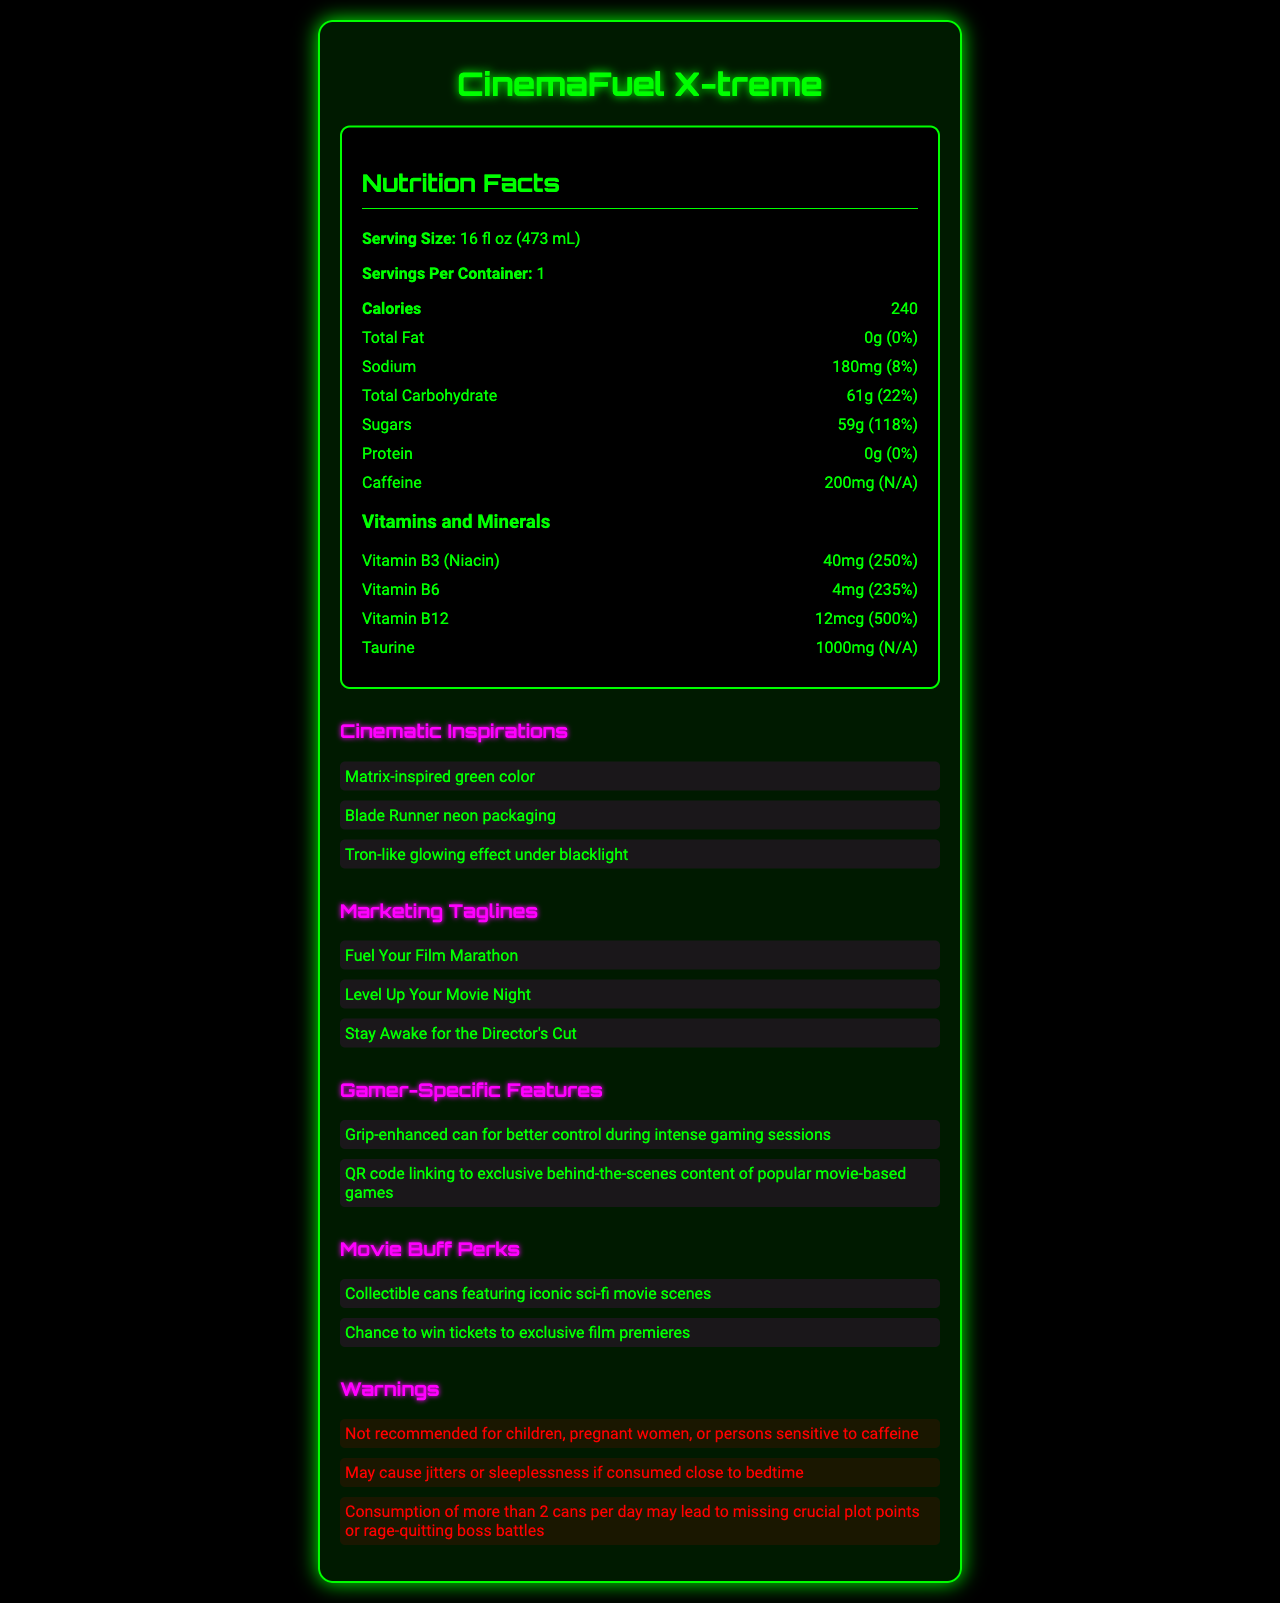what is the serving size of CinemaFuel X-treme? The document lists the serving size directly under the Nutrition Facts section as 16 fl oz (473 mL).
Answer: 16 fl oz (473 mL) how many calories are in one serving of CinemaFuel X-treme? The calorie count is found under the Nutrition Facts section, specified as 240 calories per serving.
Answer: 240 what percentage of the daily value of sugars does one serving of CinemaFuel X-treme provide? The Nutrition Facts section shows that each serving contains 59g of sugars which is 118% of the daily value.
Answer: 118% Name one vitamin included in CinemaFuel X-treme and its corresponding daily value percentage. The Vitamins and Minerals subsection lists Vitamin B12 with an amount of 12mcg and a daily value of 500%.
Answer: Vitamin B12, 500% what is CinemaFuel X-treme's sodium content? The sodium content is given as 180mg, which is 8% of the daily value, as shown in the Nutrition Facts section.
Answer: 180mg (8%) what tagline is mentioned for CinemaFuel X-treme's marketing? A. Fuel Your Study Marathon B. Fuel Your Film Marathon C. Energy for the Win The Marketing Taglines section includes "Fuel Your Film Marathon" as one of the taglines.
Answer: B which aesthetic is NOT listed as a cinematic inspiration for CinemaFuel X-treme? i. Matrix-inspired green color ii. Blade Runner neon packaging iii. Star Wars holographic visuals iv. Tron-like glowing effect under blacklight The Cinematic Inspirations section mentions inspirations from Matrix, Blade Runner, and Tron, but not Star Wars holographic visuals.
Answer: iii is CinemaFuel X-treme recommended for children? The Warnings section clearly states that the product is not recommended for children.
Answer: No summarize the main idea of the CinemaFuel X-treme document. The document combines nutritional data with marketing and product features to highlight how CinemaFuel X-treme caters to its intended audience, emphasizing its high caffeine content, vitamins, and thematic inspirations from notable sci-fi films.
Answer: CinemaFuel X-treme is an energy drink specifically designed for gamers and movie enthusiasts. It provides a high amount of caffeine and essential vitamins, has unique marketing features inspired by famous sci-fi movies, and includes features and perks tailored for its target audience. how many specific features does CinemaFuel X-treme offer for gamers? The Gamer-Specific Features section lists two features: "Grip-enhanced can for better control during intense gaming sessions" and "QR code linking to exclusive behind-the-scenes content of popular movie-based games".
Answer: 2 determine the daily value percentage for caffeine The daily value percentage for caffeine is listed as N/A in the Nutrition Facts section, indicating that it does not have a standard daily value.
Answer: Not available (N/A) what is the total carbohydrate content in CinemaFuel X-treme, and what percentage of daily value does it represent? The Nutrition Facts section indicates that the total carbohydrate content is 61g, which is 22% of the daily value.
Answer: 61g (22%) what color is CinemaFuel X-treme inspired by? The Cinematic Inspirations section mentions that CinemaFuel X-treme has a "Matrix-inspired green color."
Answer: Green how many servings are there per container of CinemaFuel X-treme? The Nutrition Facts section specifies that there is one serving per container.
Answer: 1 identify a perk a movie buff might enjoy from CinemaFuel X-treme. The Movie Buff Perks section lists "Chance to win tickets to exclusive film premieres" as one of the perks.
Answer: Chance to win tickets to exclusive film premieres which ingredient in CinemaFuel X-treme acts as a preservative? The ingredient list includes "Potassium Sorbate (Preservative)," indicating its role as a preservative.
Answer: Potassium Sorbate What is the total fat content in CinemaFuel X-treme? The Nutrition Facts section indicates that the total fat content is 0g, corresponding to 0% of the daily value.
Answer: 0g (0%) Can the calorie content of CinemaFuel X-treme be altered based on the information provided? The document provides a fixed calorie content of 240 per serving, with no information on altering it.
Answer: No 